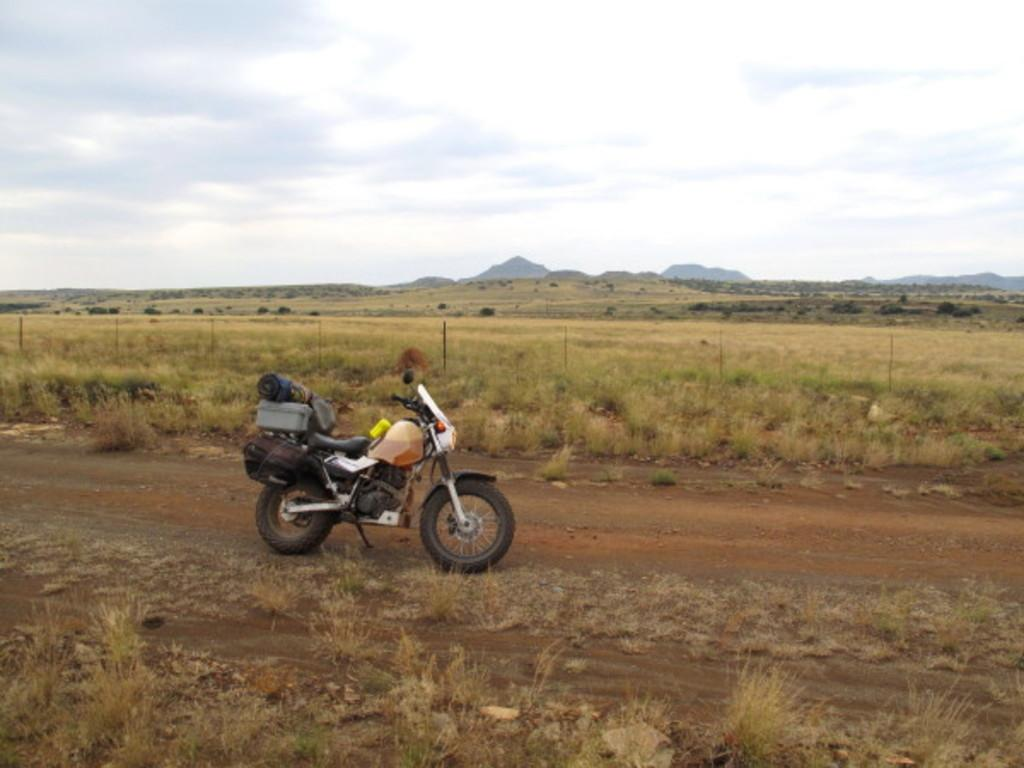What object is blocking the path in the image? There is a bike parked in the path. What type of vegetation can be seen on the ground in the image? There is dried grass on the ground. What can be seen in the distance in the image? Hills are visible in the background. What is visible above the hills in the image? The sky is visible in the background. What is present in the sky in the image? Clouds are present in the sky. What type of pies are being sold at the bike shop in the image? There is no bike shop or pies present in the image; it only shows a bike parked in the path. 